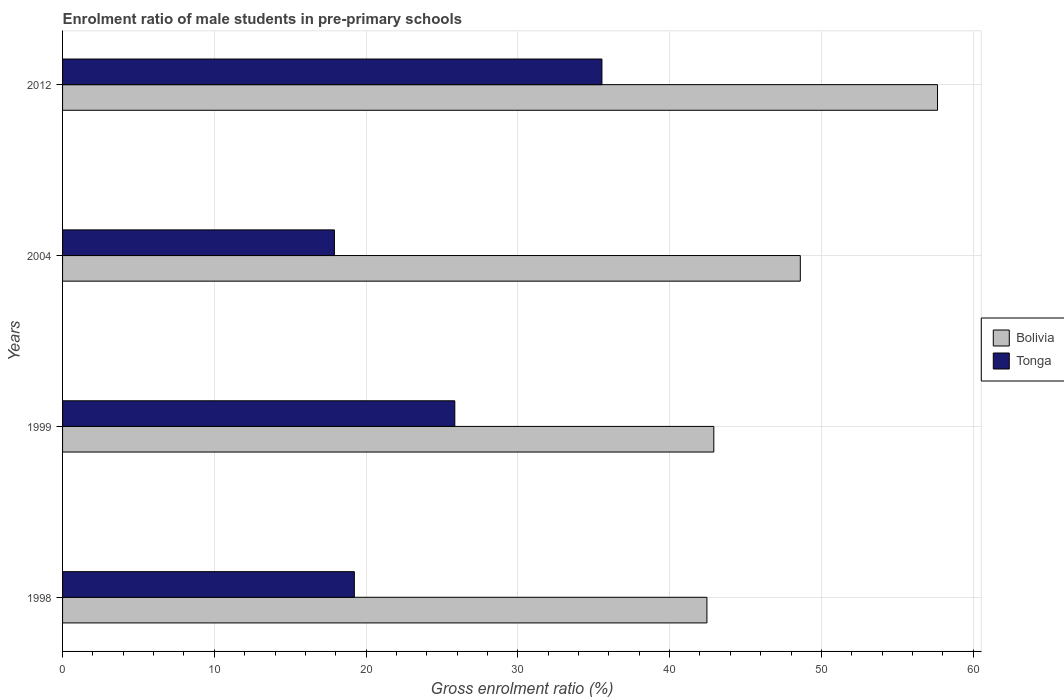How many groups of bars are there?
Your answer should be very brief. 4. How many bars are there on the 1st tick from the top?
Make the answer very short. 2. How many bars are there on the 3rd tick from the bottom?
Make the answer very short. 2. What is the label of the 2nd group of bars from the top?
Keep it short and to the point. 2004. What is the enrolment ratio of male students in pre-primary schools in Bolivia in 2004?
Offer a terse response. 48.61. Across all years, what is the maximum enrolment ratio of male students in pre-primary schools in Tonga?
Ensure brevity in your answer.  35.54. Across all years, what is the minimum enrolment ratio of male students in pre-primary schools in Bolivia?
Make the answer very short. 42.46. In which year was the enrolment ratio of male students in pre-primary schools in Bolivia maximum?
Keep it short and to the point. 2012. What is the total enrolment ratio of male students in pre-primary schools in Bolivia in the graph?
Your answer should be compact. 191.64. What is the difference between the enrolment ratio of male students in pre-primary schools in Tonga in 1999 and that in 2012?
Your response must be concise. -9.69. What is the difference between the enrolment ratio of male students in pre-primary schools in Tonga in 1998 and the enrolment ratio of male students in pre-primary schools in Bolivia in 2012?
Offer a very short reply. -38.43. What is the average enrolment ratio of male students in pre-primary schools in Bolivia per year?
Offer a very short reply. 47.91. In the year 1999, what is the difference between the enrolment ratio of male students in pre-primary schools in Bolivia and enrolment ratio of male students in pre-primary schools in Tonga?
Offer a terse response. 17.07. What is the ratio of the enrolment ratio of male students in pre-primary schools in Tonga in 1999 to that in 2004?
Your answer should be compact. 1.44. What is the difference between the highest and the second highest enrolment ratio of male students in pre-primary schools in Bolivia?
Your answer should be very brief. 9.04. What is the difference between the highest and the lowest enrolment ratio of male students in pre-primary schools in Tonga?
Your response must be concise. 17.63. In how many years, is the enrolment ratio of male students in pre-primary schools in Tonga greater than the average enrolment ratio of male students in pre-primary schools in Tonga taken over all years?
Keep it short and to the point. 2. What does the 2nd bar from the top in 1998 represents?
Your answer should be very brief. Bolivia. Are all the bars in the graph horizontal?
Give a very brief answer. Yes. How many years are there in the graph?
Offer a terse response. 4. Are the values on the major ticks of X-axis written in scientific E-notation?
Keep it short and to the point. No. Does the graph contain any zero values?
Provide a short and direct response. No. Does the graph contain grids?
Offer a very short reply. Yes. Where does the legend appear in the graph?
Ensure brevity in your answer.  Center right. How are the legend labels stacked?
Make the answer very short. Vertical. What is the title of the graph?
Provide a short and direct response. Enrolment ratio of male students in pre-primary schools. Does "Eritrea" appear as one of the legend labels in the graph?
Make the answer very short. No. What is the Gross enrolment ratio (%) in Bolivia in 1998?
Your answer should be very brief. 42.46. What is the Gross enrolment ratio (%) of Tonga in 1998?
Give a very brief answer. 19.23. What is the Gross enrolment ratio (%) of Bolivia in 1999?
Your answer should be compact. 42.91. What is the Gross enrolment ratio (%) in Tonga in 1999?
Make the answer very short. 25.85. What is the Gross enrolment ratio (%) in Bolivia in 2004?
Provide a short and direct response. 48.61. What is the Gross enrolment ratio (%) of Tonga in 2004?
Keep it short and to the point. 17.91. What is the Gross enrolment ratio (%) in Bolivia in 2012?
Your answer should be compact. 57.65. What is the Gross enrolment ratio (%) of Tonga in 2012?
Provide a succinct answer. 35.54. Across all years, what is the maximum Gross enrolment ratio (%) in Bolivia?
Your response must be concise. 57.65. Across all years, what is the maximum Gross enrolment ratio (%) of Tonga?
Your answer should be very brief. 35.54. Across all years, what is the minimum Gross enrolment ratio (%) in Bolivia?
Provide a short and direct response. 42.46. Across all years, what is the minimum Gross enrolment ratio (%) in Tonga?
Your response must be concise. 17.91. What is the total Gross enrolment ratio (%) of Bolivia in the graph?
Your answer should be compact. 191.64. What is the total Gross enrolment ratio (%) in Tonga in the graph?
Ensure brevity in your answer.  98.53. What is the difference between the Gross enrolment ratio (%) in Bolivia in 1998 and that in 1999?
Your answer should be compact. -0.45. What is the difference between the Gross enrolment ratio (%) of Tonga in 1998 and that in 1999?
Your answer should be compact. -6.62. What is the difference between the Gross enrolment ratio (%) in Bolivia in 1998 and that in 2004?
Your answer should be very brief. -6.15. What is the difference between the Gross enrolment ratio (%) of Tonga in 1998 and that in 2004?
Your answer should be very brief. 1.31. What is the difference between the Gross enrolment ratio (%) in Bolivia in 1998 and that in 2012?
Make the answer very short. -15.2. What is the difference between the Gross enrolment ratio (%) in Tonga in 1998 and that in 2012?
Provide a succinct answer. -16.31. What is the difference between the Gross enrolment ratio (%) of Bolivia in 1999 and that in 2004?
Offer a very short reply. -5.7. What is the difference between the Gross enrolment ratio (%) of Tonga in 1999 and that in 2004?
Provide a short and direct response. 7.93. What is the difference between the Gross enrolment ratio (%) of Bolivia in 1999 and that in 2012?
Offer a terse response. -14.74. What is the difference between the Gross enrolment ratio (%) in Tonga in 1999 and that in 2012?
Keep it short and to the point. -9.69. What is the difference between the Gross enrolment ratio (%) of Bolivia in 2004 and that in 2012?
Provide a short and direct response. -9.04. What is the difference between the Gross enrolment ratio (%) of Tonga in 2004 and that in 2012?
Your answer should be very brief. -17.63. What is the difference between the Gross enrolment ratio (%) in Bolivia in 1998 and the Gross enrolment ratio (%) in Tonga in 1999?
Your answer should be compact. 16.61. What is the difference between the Gross enrolment ratio (%) of Bolivia in 1998 and the Gross enrolment ratio (%) of Tonga in 2004?
Offer a very short reply. 24.55. What is the difference between the Gross enrolment ratio (%) of Bolivia in 1998 and the Gross enrolment ratio (%) of Tonga in 2012?
Your answer should be very brief. 6.92. What is the difference between the Gross enrolment ratio (%) of Bolivia in 1999 and the Gross enrolment ratio (%) of Tonga in 2004?
Offer a terse response. 25. What is the difference between the Gross enrolment ratio (%) of Bolivia in 1999 and the Gross enrolment ratio (%) of Tonga in 2012?
Make the answer very short. 7.37. What is the difference between the Gross enrolment ratio (%) in Bolivia in 2004 and the Gross enrolment ratio (%) in Tonga in 2012?
Offer a terse response. 13.07. What is the average Gross enrolment ratio (%) in Bolivia per year?
Your answer should be very brief. 47.91. What is the average Gross enrolment ratio (%) of Tonga per year?
Offer a very short reply. 24.63. In the year 1998, what is the difference between the Gross enrolment ratio (%) in Bolivia and Gross enrolment ratio (%) in Tonga?
Offer a terse response. 23.23. In the year 1999, what is the difference between the Gross enrolment ratio (%) in Bolivia and Gross enrolment ratio (%) in Tonga?
Make the answer very short. 17.07. In the year 2004, what is the difference between the Gross enrolment ratio (%) of Bolivia and Gross enrolment ratio (%) of Tonga?
Make the answer very short. 30.7. In the year 2012, what is the difference between the Gross enrolment ratio (%) of Bolivia and Gross enrolment ratio (%) of Tonga?
Keep it short and to the point. 22.11. What is the ratio of the Gross enrolment ratio (%) of Bolivia in 1998 to that in 1999?
Provide a succinct answer. 0.99. What is the ratio of the Gross enrolment ratio (%) in Tonga in 1998 to that in 1999?
Keep it short and to the point. 0.74. What is the ratio of the Gross enrolment ratio (%) in Bolivia in 1998 to that in 2004?
Keep it short and to the point. 0.87. What is the ratio of the Gross enrolment ratio (%) of Tonga in 1998 to that in 2004?
Offer a very short reply. 1.07. What is the ratio of the Gross enrolment ratio (%) of Bolivia in 1998 to that in 2012?
Give a very brief answer. 0.74. What is the ratio of the Gross enrolment ratio (%) in Tonga in 1998 to that in 2012?
Offer a terse response. 0.54. What is the ratio of the Gross enrolment ratio (%) in Bolivia in 1999 to that in 2004?
Your answer should be very brief. 0.88. What is the ratio of the Gross enrolment ratio (%) in Tonga in 1999 to that in 2004?
Your answer should be compact. 1.44. What is the ratio of the Gross enrolment ratio (%) in Bolivia in 1999 to that in 2012?
Ensure brevity in your answer.  0.74. What is the ratio of the Gross enrolment ratio (%) in Tonga in 1999 to that in 2012?
Ensure brevity in your answer.  0.73. What is the ratio of the Gross enrolment ratio (%) in Bolivia in 2004 to that in 2012?
Keep it short and to the point. 0.84. What is the ratio of the Gross enrolment ratio (%) in Tonga in 2004 to that in 2012?
Your answer should be very brief. 0.5. What is the difference between the highest and the second highest Gross enrolment ratio (%) in Bolivia?
Give a very brief answer. 9.04. What is the difference between the highest and the second highest Gross enrolment ratio (%) of Tonga?
Ensure brevity in your answer.  9.69. What is the difference between the highest and the lowest Gross enrolment ratio (%) of Bolivia?
Your answer should be compact. 15.2. What is the difference between the highest and the lowest Gross enrolment ratio (%) in Tonga?
Your response must be concise. 17.63. 